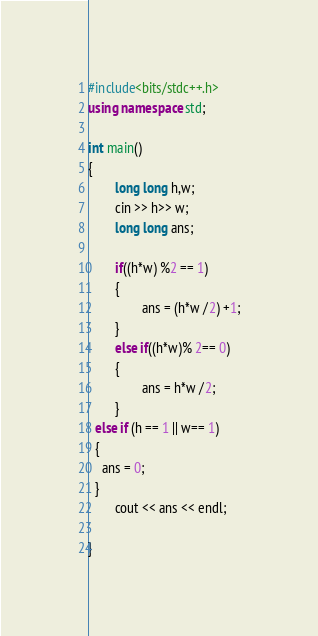Convert code to text. <code><loc_0><loc_0><loc_500><loc_500><_C++_>#include<bits/stdc++.h>
using namespace std;

int main()
{
        long long h,w;
        cin >> h>> w;
        long long ans;
 
        if((h*w) %2 == 1)
        {       
                ans = (h*w /2) +1;
        }
        else if((h*w)% 2== 0)
        {
                ans = h*w /2;
        }
  else if (h == 1 || w== 1)
  {
    ans = 0;
  }
        cout << ans << endl;

}

</code> 